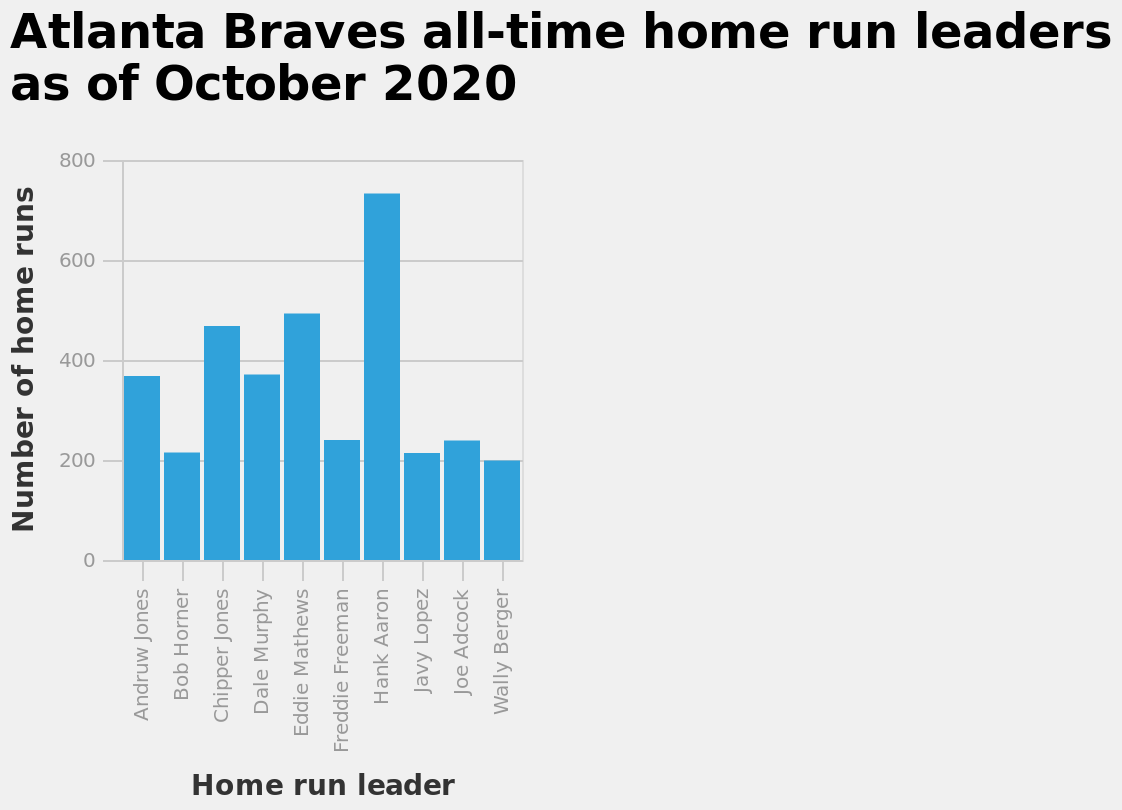<image>
please summary the statistics and relations of the chart The home run leader with the most runs is Hank Aaron with over 700 home runs. The home run leader with the least home runs is Waller Berger with 200 home runs. Bob Horner, Freddie Freeman, Javy Lopez and Joe Adcock all have a similar amount of home run totals in the 200s. Is the bar chart specific to a certain period? Yes, the bar chart represents the Atlanta Braves all-time home run leaders as of October 2020. 